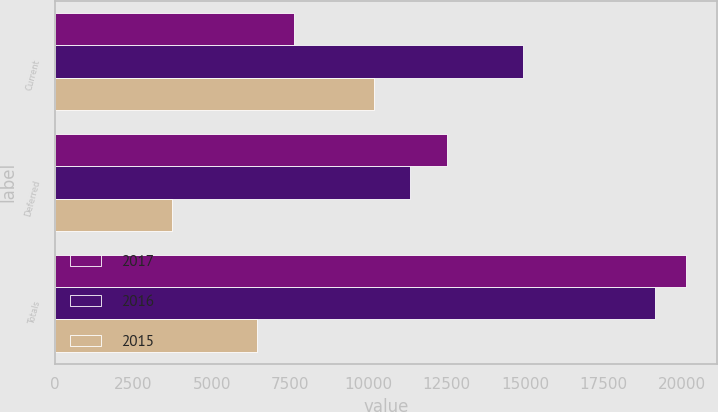<chart> <loc_0><loc_0><loc_500><loc_500><stacked_bar_chart><ecel><fcel>Current<fcel>Deferred<fcel>Totals<nl><fcel>2017<fcel>7633<fcel>12495<fcel>20128<nl><fcel>2016<fcel>14944<fcel>11336<fcel>19128<nl><fcel>2015<fcel>10177<fcel>3726<fcel>6451<nl></chart> 